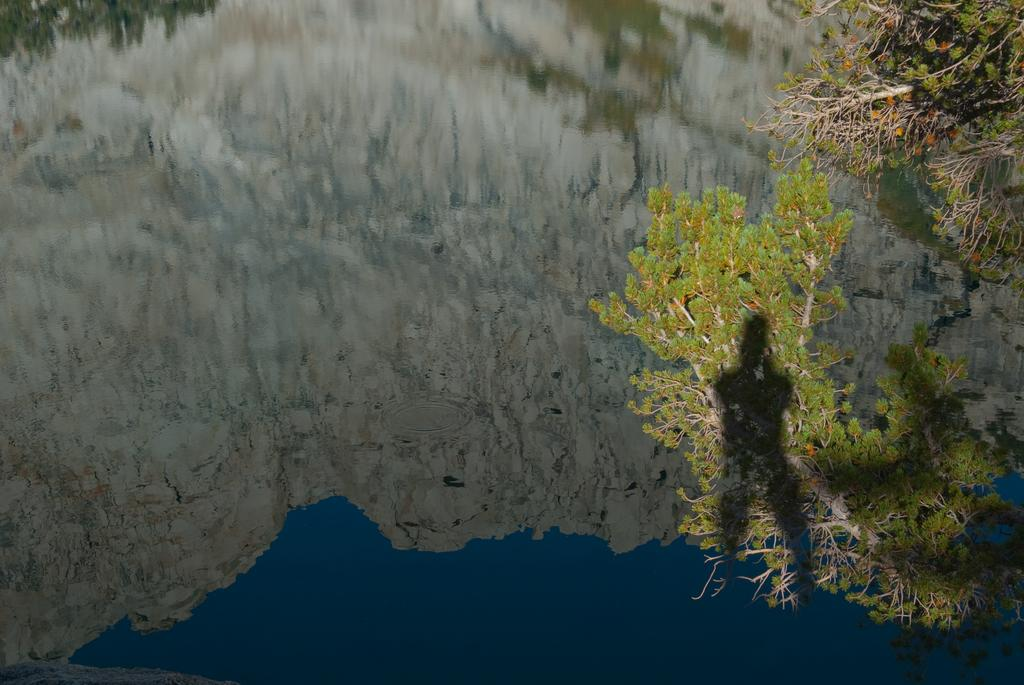What type of vegetation can be seen in the image? There are trees in the image. What natural element is visible in the image besides the trees? There is water visible in the image. What type of hair can be seen on the trees in the image? There is no hair present on the trees in the image; they are simply trees with leaves or branches. 